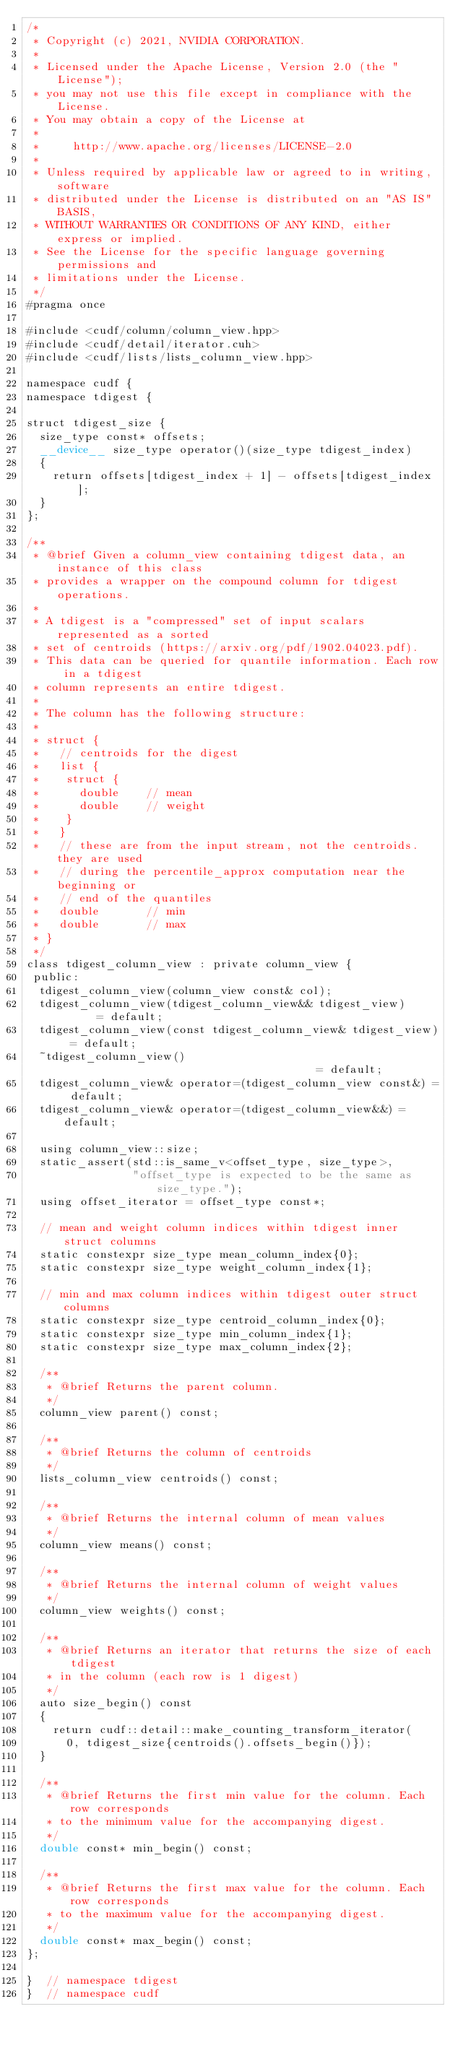<code> <loc_0><loc_0><loc_500><loc_500><_Cuda_>/*
 * Copyright (c) 2021, NVIDIA CORPORATION.
 *
 * Licensed under the Apache License, Version 2.0 (the "License");
 * you may not use this file except in compliance with the License.
 * You may obtain a copy of the License at
 *
 *     http://www.apache.org/licenses/LICENSE-2.0
 *
 * Unless required by applicable law or agreed to in writing, software
 * distributed under the License is distributed on an "AS IS" BASIS,
 * WITHOUT WARRANTIES OR CONDITIONS OF ANY KIND, either express or implied.
 * See the License for the specific language governing permissions and
 * limitations under the License.
 */
#pragma once

#include <cudf/column/column_view.hpp>
#include <cudf/detail/iterator.cuh>
#include <cudf/lists/lists_column_view.hpp>

namespace cudf {
namespace tdigest {

struct tdigest_size {
  size_type const* offsets;
  __device__ size_type operator()(size_type tdigest_index)
  {
    return offsets[tdigest_index + 1] - offsets[tdigest_index];
  }
};

/**
 * @brief Given a column_view containing tdigest data, an instance of this class
 * provides a wrapper on the compound column for tdigest operations.
 *
 * A tdigest is a "compressed" set of input scalars represented as a sorted
 * set of centroids (https://arxiv.org/pdf/1902.04023.pdf).
 * This data can be queried for quantile information. Each row in a tdigest
 * column represents an entire tdigest.
 *
 * The column has the following structure:
 *
 * struct {
 *   // centroids for the digest
 *   list {
 *    struct {
 *      double    // mean
 *      double    // weight
 *    }
 *   }
 *   // these are from the input stream, not the centroids. they are used
 *   // during the percentile_approx computation near the beginning or
 *   // end of the quantiles
 *   double       // min
 *   double       // max
 * }
 */
class tdigest_column_view : private column_view {
 public:
  tdigest_column_view(column_view const& col);
  tdigest_column_view(tdigest_column_view&& tdigest_view)      = default;
  tdigest_column_view(const tdigest_column_view& tdigest_view) = default;
  ~tdigest_column_view()                                       = default;
  tdigest_column_view& operator=(tdigest_column_view const&) = default;
  tdigest_column_view& operator=(tdigest_column_view&&) = default;

  using column_view::size;
  static_assert(std::is_same_v<offset_type, size_type>,
                "offset_type is expected to be the same as size_type.");
  using offset_iterator = offset_type const*;

  // mean and weight column indices within tdigest inner struct columns
  static constexpr size_type mean_column_index{0};
  static constexpr size_type weight_column_index{1};

  // min and max column indices within tdigest outer struct columns
  static constexpr size_type centroid_column_index{0};
  static constexpr size_type min_column_index{1};
  static constexpr size_type max_column_index{2};

  /**
   * @brief Returns the parent column.
   */
  column_view parent() const;

  /**
   * @brief Returns the column of centroids
   */
  lists_column_view centroids() const;

  /**
   * @brief Returns the internal column of mean values
   */
  column_view means() const;

  /**
   * @brief Returns the internal column of weight values
   */
  column_view weights() const;

  /**
   * @brief Returns an iterator that returns the size of each tdigest
   * in the column (each row is 1 digest)
   */
  auto size_begin() const
  {
    return cudf::detail::make_counting_transform_iterator(
      0, tdigest_size{centroids().offsets_begin()});
  }

  /**
   * @brief Returns the first min value for the column. Each row corresponds
   * to the minimum value for the accompanying digest.
   */
  double const* min_begin() const;

  /**
   * @brief Returns the first max value for the column. Each row corresponds
   * to the maximum value for the accompanying digest.
   */
  double const* max_begin() const;
};

}  // namespace tdigest
}  // namespace cudf
</code> 